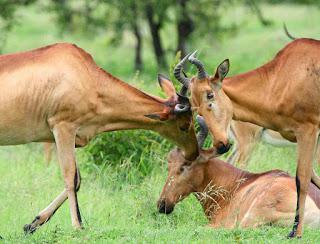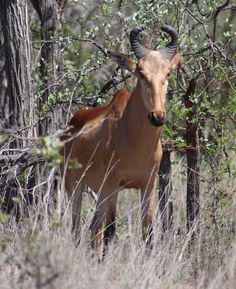The first image is the image on the left, the second image is the image on the right. Assess this claim about the two images: "The left image includes more than twice the number of horned animals as the right image.". Correct or not? Answer yes or no. Yes. The first image is the image on the left, the second image is the image on the right. Evaluate the accuracy of this statement regarding the images: "There is exactly one animal standing in the right image.". Is it true? Answer yes or no. Yes. 